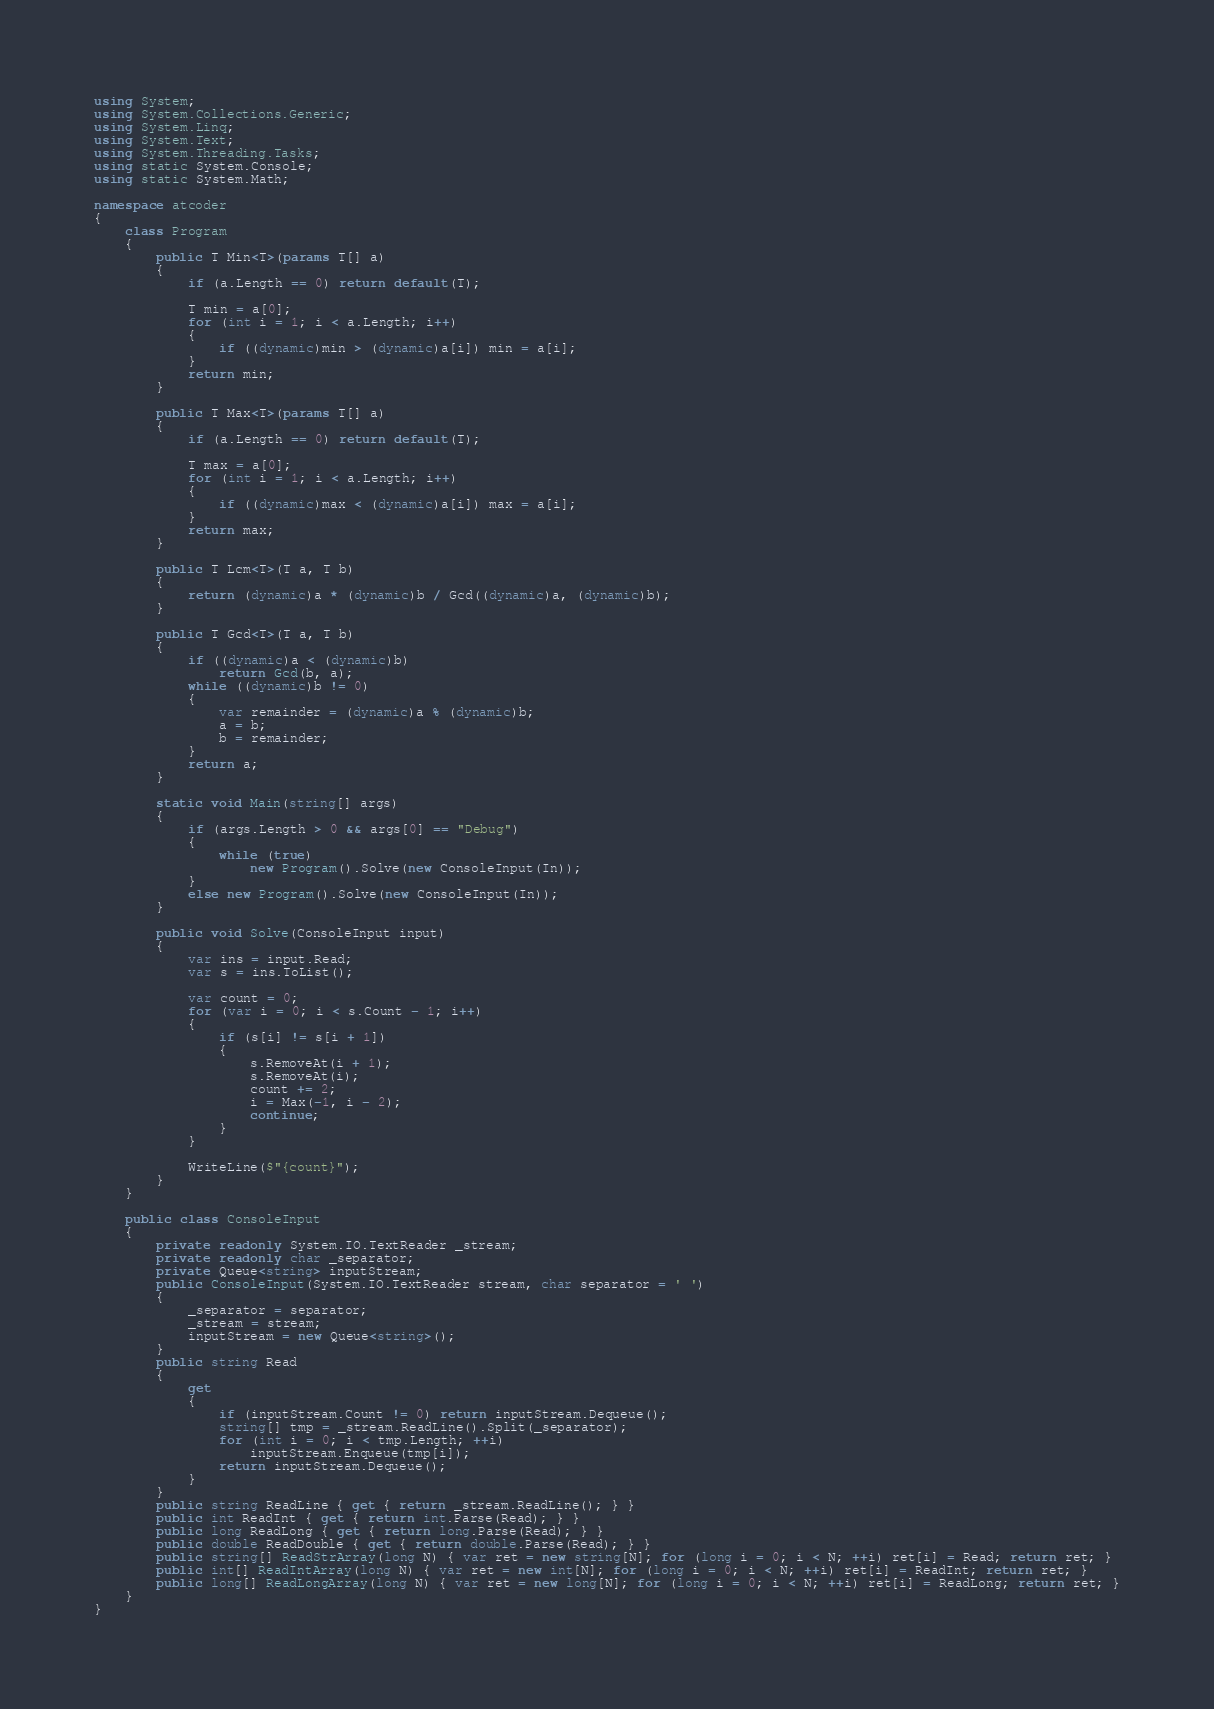<code> <loc_0><loc_0><loc_500><loc_500><_C#_>using System;
using System.Collections.Generic;
using System.Linq;
using System.Text;
using System.Threading.Tasks;
using static System.Console;
using static System.Math;

namespace atcoder
{
    class Program
    {
        public T Min<T>(params T[] a)
        {
            if (a.Length == 0) return default(T);

            T min = a[0];
            for (int i = 1; i < a.Length; i++)
            {
                if ((dynamic)min > (dynamic)a[i]) min = a[i];
            }
            return min;
        }

        public T Max<T>(params T[] a)
        {
            if (a.Length == 0) return default(T);

            T max = a[0];
            for (int i = 1; i < a.Length; i++)
            {
                if ((dynamic)max < (dynamic)a[i]) max = a[i];
            }
            return max;
        }

        public T Lcm<T>(T a, T b)
        {
            return (dynamic)a * (dynamic)b / Gcd((dynamic)a, (dynamic)b);
        }

        public T Gcd<T>(T a, T b)
        {
            if ((dynamic)a < (dynamic)b)
                return Gcd(b, a);
            while ((dynamic)b != 0)
            {
                var remainder = (dynamic)a % (dynamic)b;
                a = b;
                b = remainder;
            }
            return a;
        }

        static void Main(string[] args)
        {
            if (args.Length > 0 && args[0] == "Debug")
            {
                while (true)
                    new Program().Solve(new ConsoleInput(In));
            }
            else new Program().Solve(new ConsoleInput(In));
        }

        public void Solve(ConsoleInput input)
        {
            var ins = input.Read;
            var s = ins.ToList();

            var count = 0;
            for (var i = 0; i < s.Count - 1; i++)
            {
                if (s[i] != s[i + 1])
                {
                    s.RemoveAt(i + 1);
                    s.RemoveAt(i);
                    count += 2;
                    i = Max(-1, i - 2);
                    continue;
                }
            }

            WriteLine($"{count}");
        }
    }

    public class ConsoleInput
    {
        private readonly System.IO.TextReader _stream;
        private readonly char _separator;
        private Queue<string> inputStream;
        public ConsoleInput(System.IO.TextReader stream, char separator = ' ')
        {
            _separator = separator;
            _stream = stream;
            inputStream = new Queue<string>();
        }
        public string Read
        {
            get
            {
                if (inputStream.Count != 0) return inputStream.Dequeue();
                string[] tmp = _stream.ReadLine().Split(_separator);
                for (int i = 0; i < tmp.Length; ++i)
                    inputStream.Enqueue(tmp[i]);
                return inputStream.Dequeue();
            }
        }
        public string ReadLine { get { return _stream.ReadLine(); } }
        public int ReadInt { get { return int.Parse(Read); } }
        public long ReadLong { get { return long.Parse(Read); } }
        public double ReadDouble { get { return double.Parse(Read); } }
        public string[] ReadStrArray(long N) { var ret = new string[N]; for (long i = 0; i < N; ++i) ret[i] = Read; return ret; }
        public int[] ReadIntArray(long N) { var ret = new int[N]; for (long i = 0; i < N; ++i) ret[i] = ReadInt; return ret; }
        public long[] ReadLongArray(long N) { var ret = new long[N]; for (long i = 0; i < N; ++i) ret[i] = ReadLong; return ret; }
    }
}
</code> 